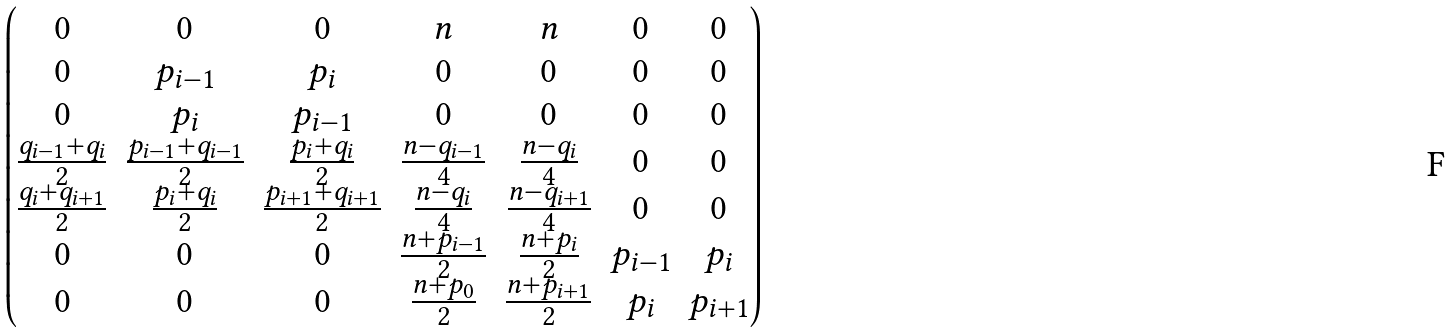<formula> <loc_0><loc_0><loc_500><loc_500>\begin{pmatrix} 0 & 0 & 0 & n & n & 0 & 0 \\ 0 & p _ { i - 1 } & p _ { i } & 0 & 0 & 0 & 0 \\ 0 & p _ { i } & p _ { i - 1 } & 0 & 0 & 0 & 0 \\ \frac { q _ { i - 1 } + q _ { i } } { 2 } & \frac { p _ { i - 1 } + q _ { i - 1 } } { 2 } & \frac { p _ { i } + q _ { i } } { 2 } & \frac { n - q _ { i - 1 } } { 4 } & \frac { n - q _ { i } } { 4 } & 0 & 0 \\ \frac { q _ { i } + q _ { i + 1 } } { 2 } & \frac { p _ { i } + q _ { i } } { 2 } & \frac { p _ { i + 1 } + q _ { i + 1 } } { 2 } & \frac { n - q _ { i } } { 4 } & \frac { n - q _ { i + 1 } } { 4 } & 0 & 0 \\ 0 & 0 & 0 & \frac { n + p _ { i - 1 } } { 2 } & \frac { n + p _ { i } } { 2 } & p _ { i - 1 } & p _ { i } \\ 0 & 0 & 0 & \frac { n + p _ { 0 } } { 2 } & \frac { n + p _ { i + 1 } } { 2 } & p _ { i } & p _ { i + 1 } \end{pmatrix}</formula> 